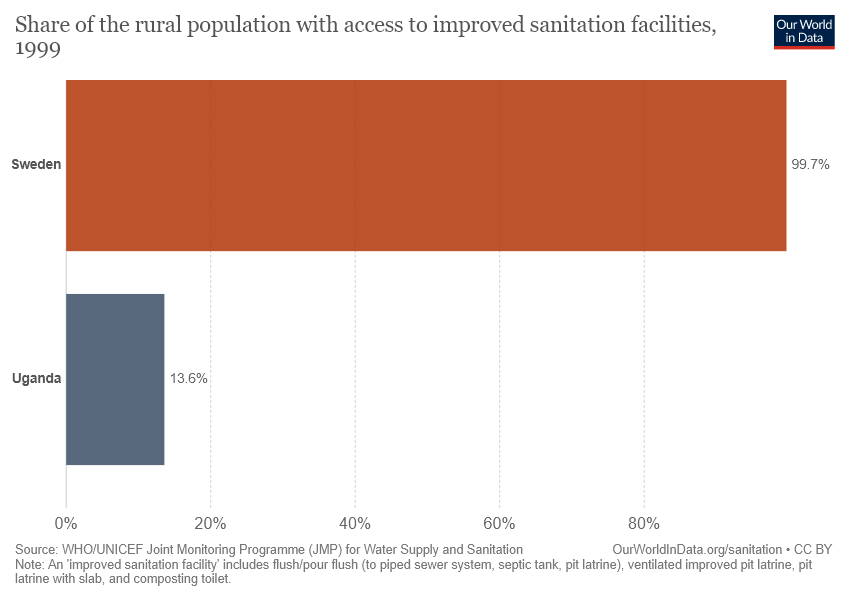Identify some key points in this picture. In Sweden, 99.7% of the rural population has access to improved sanitation facilities. The ratio of the sum and difference of two percentage values, without considering decimal values, is 1.31. 